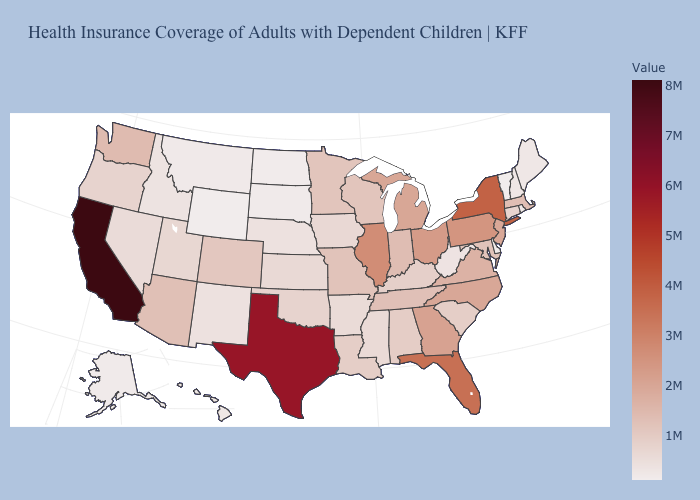Among the states that border Iowa , does Illinois have the lowest value?
Answer briefly. No. Does California have the highest value in the USA?
Concise answer only. Yes. Among the states that border Montana , which have the highest value?
Concise answer only. Idaho. Among the states that border Montana , which have the highest value?
Give a very brief answer. Idaho. Does Vermont have the lowest value in the Northeast?
Write a very short answer. Yes. 